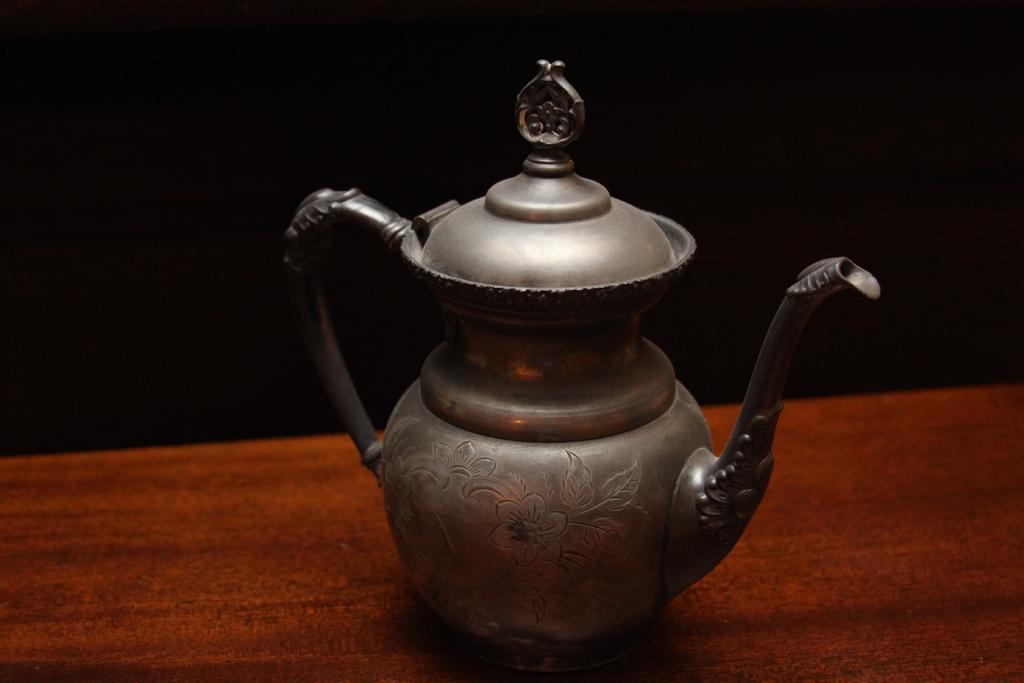Please provide a concise description of this image. In this picture there is a teapot on the table and there is a floral design on the teapot. At the back there is a black background. 